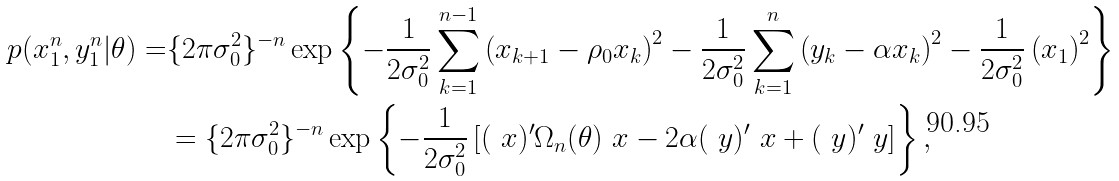<formula> <loc_0><loc_0><loc_500><loc_500>p ( x _ { 1 } ^ { n } , y _ { 1 } ^ { n } | \theta ) = & \{ 2 \pi \sigma _ { 0 } ^ { 2 } \} ^ { - n } \exp \left \{ - \frac { 1 } { 2 \sigma _ { 0 } ^ { 2 } } \sum _ { k = 1 } ^ { n - 1 } \left ( x _ { k + 1 } - \rho _ { 0 } x _ { k } \right ) ^ { 2 } - \frac { 1 } { 2 \sigma _ { 0 } ^ { 2 } } \sum _ { k = 1 } ^ { n } \left ( y _ { k } - \alpha x _ { k } \right ) ^ { 2 } - \frac { 1 } { 2 \sigma _ { 0 } ^ { 2 } } \left ( x _ { 1 } \right ) ^ { 2 } \right \} \\ & = \{ 2 \pi \sigma ^ { 2 } _ { 0 } \} ^ { - n } \exp \left \{ - \frac { 1 } { 2 \sigma _ { 0 } ^ { 2 } } \left [ ( \ x ) ^ { \prime } \Omega _ { n } ( \theta ) \ x - 2 \alpha ( \ y ) ^ { \prime } \ x + ( \ y ) ^ { \prime } \ y \right ] \right \} ,</formula> 